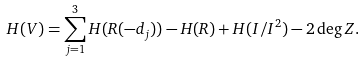<formula> <loc_0><loc_0><loc_500><loc_500>H ( V ) = \sum _ { j = 1 } ^ { 3 } H ( R ( - d _ { j } ) ) - H ( R ) + H ( I / I ^ { 2 } ) - 2 \deg Z .</formula> 